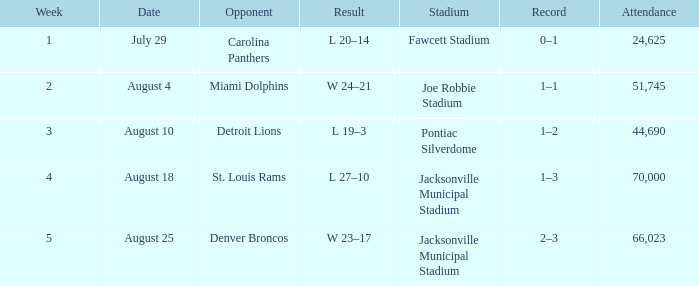WHEN has a Opponent of miami dolphins? August 4. 